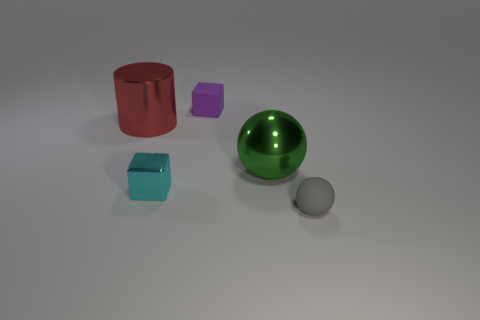Is the material of the big red cylinder the same as the sphere that is to the right of the big green shiny sphere?
Keep it short and to the point. No. Are there an equal number of tiny matte objects in front of the gray rubber ball and small purple objects?
Ensure brevity in your answer.  No. The large thing that is left of the purple cube is what color?
Keep it short and to the point. Red. What number of other objects are the same color as the rubber sphere?
Offer a terse response. 0. Is there anything else that has the same size as the red cylinder?
Your response must be concise. Yes. There is a matte object that is behind the cyan cube; is it the same size as the large green thing?
Give a very brief answer. No. What is the tiny object that is to the right of the tiny rubber cube made of?
Provide a short and direct response. Rubber. Is there anything else that is the same shape as the large red metal thing?
Offer a terse response. No. What number of shiny things are either small yellow spheres or balls?
Ensure brevity in your answer.  1. Are there fewer gray spheres left of the purple rubber object than blue metal blocks?
Provide a short and direct response. No. 